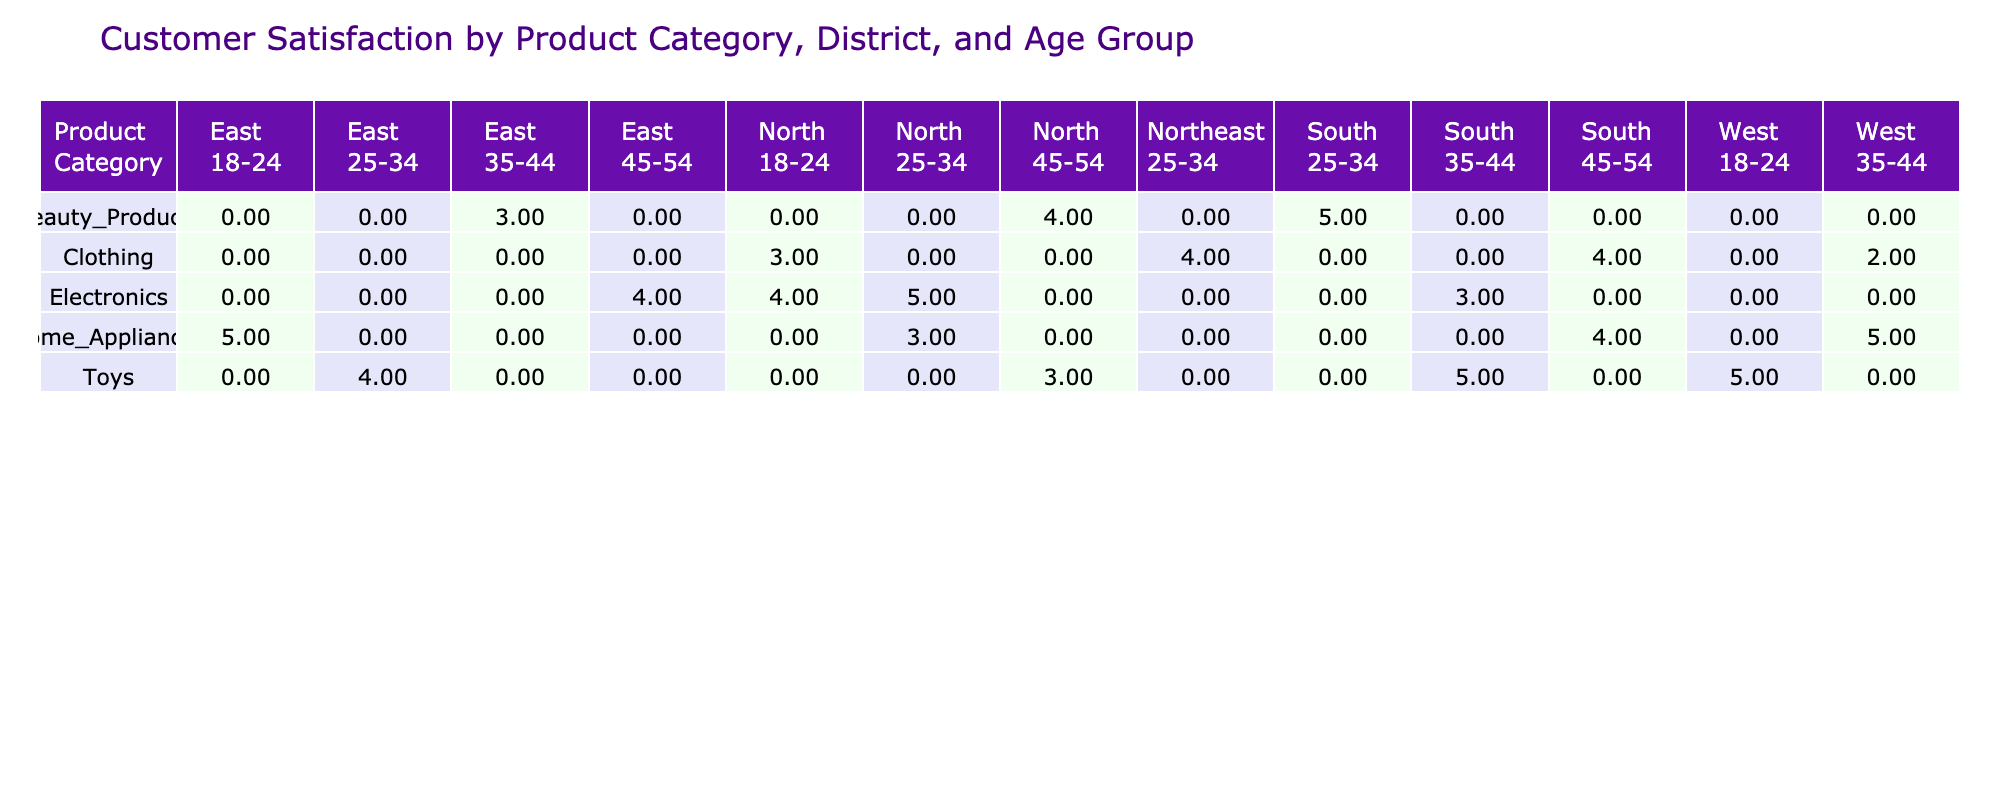What is the customer satisfaction rating for Electronics in the North district for the age group 25-34? Looking specifically at the row for Electronics and the North district, we find the customer satisfaction rating for the age group 25-34 is 5.
Answer: 5 What is the average customer satisfaction rating for Clothing in the South district? There is one entry for Clothing in the South district, which has a satisfaction rating of 4. Since there is only one value, the average is also 4.
Answer: 4 Is the customer satisfaction rating for Home Appliances in the East district above 4? Checking the row for Home Appliances in the East district, the customer satisfaction rating is 5, which is indeed above 4.
Answer: Yes Which product category has the highest average customer satisfaction rating across all districts? To find the highest average, we need to calculate the average for each product category: Electronics averages 4.0, Clothing averages 3.25, Home Appliances averages 4.25, Beauty Products averages 4.0, and Toys averages 4.25. Home Appliances and Toys tie for the highest average at 4.25.
Answer: Home Appliances and Toys For the age group 18-24, which district shows the highest customer satisfaction rating for Toys? In the Toys category for the age group 18-24, the ratings are: West is 5, East is 4, South is 5, and North is 3. West and South districts both have the highest rating at 5.
Answer: West and South What is the total customer satisfaction rating for all products in the South district? Adding the satisfaction ratings for the South district across all product categories: 3 (Electronics) + 4 (Clothing) + 4 (Home Appliances) + 5 (Beauty Products) + 5 (Toys) = 21.
Answer: 21 Are customer satisfaction ratings for Beauty Products consistently higher than 4 across all districts? Analyzing the ratings for Beauty Products: in the South district it is 5, East it is 3, and North it is 4. Since the East district has a rating below 4 (3), the statement is false.
Answer: No Which age group had the lowest customer satisfaction rating for Clothing? The ratings for Clothing across the different age groups are: 3 (18-24), 4 (25-34), 2 (35-44), and 4 (45-54). The lowest rating is 2 for the 35-44 age group.
Answer: 35-44 What is the difference between the highest and lowest customer satisfaction rating for Home Appliances? The ratings for Home Appliances are: 5 (18-24), 3 (25-34), 5 (35-44), and 4 (45-54). The highest rating is 5 and the lowest is 3. The difference is 5 - 3 = 2.
Answer: 2 